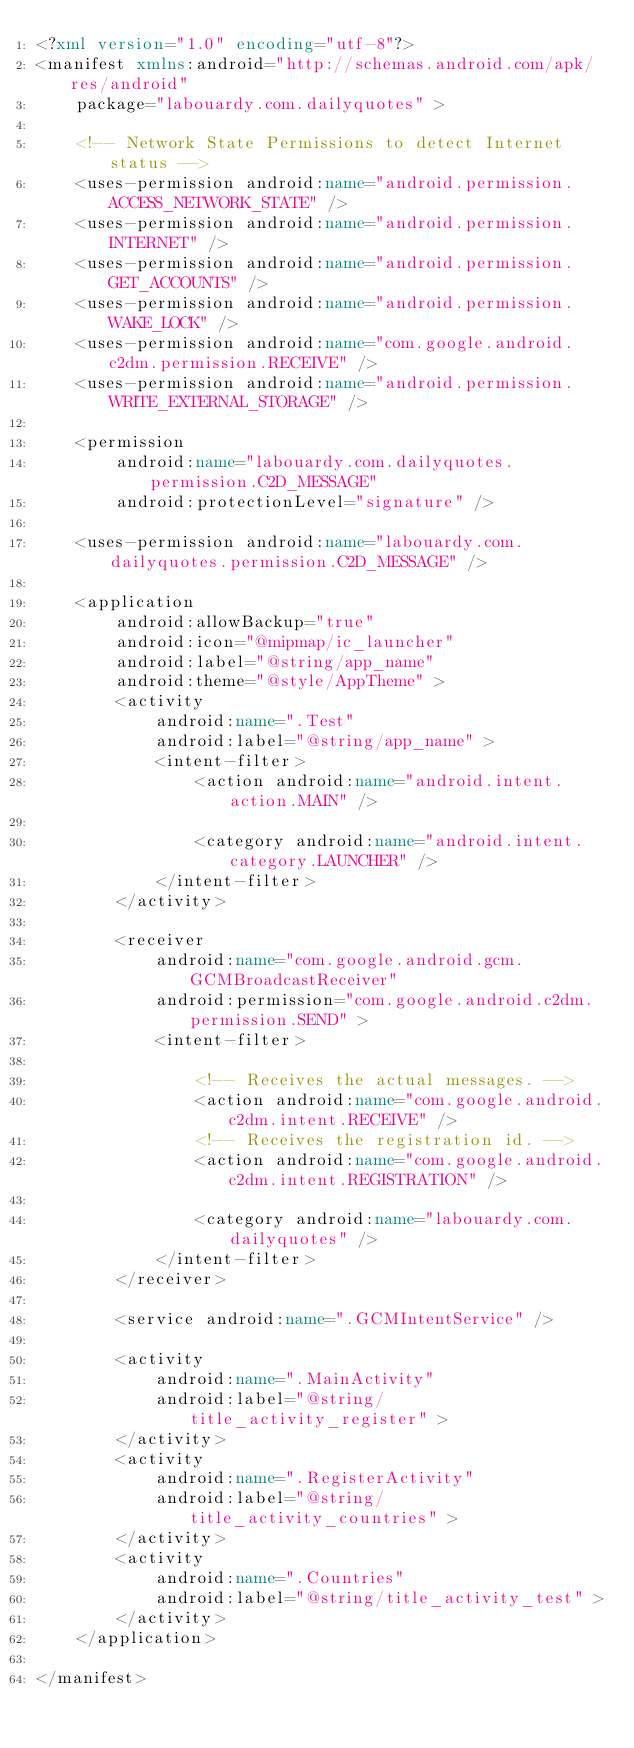<code> <loc_0><loc_0><loc_500><loc_500><_XML_><?xml version="1.0" encoding="utf-8"?>
<manifest xmlns:android="http://schemas.android.com/apk/res/android"
    package="labouardy.com.dailyquotes" >

    <!-- Network State Permissions to detect Internet status -->
    <uses-permission android:name="android.permission.ACCESS_NETWORK_STATE" />
    <uses-permission android:name="android.permission.INTERNET" />
    <uses-permission android:name="android.permission.GET_ACCOUNTS" />
    <uses-permission android:name="android.permission.WAKE_LOCK" />
    <uses-permission android:name="com.google.android.c2dm.permission.RECEIVE" />
    <uses-permission android:name="android.permission.WRITE_EXTERNAL_STORAGE" />

    <permission
        android:name="labouardy.com.dailyquotes.permission.C2D_MESSAGE"
        android:protectionLevel="signature" />

    <uses-permission android:name="labouardy.com.dailyquotes.permission.C2D_MESSAGE" />

    <application
        android:allowBackup="true"
        android:icon="@mipmap/ic_launcher"
        android:label="@string/app_name"
        android:theme="@style/AppTheme" >
        <activity
            android:name=".Test"
            android:label="@string/app_name" >
            <intent-filter>
                <action android:name="android.intent.action.MAIN" />

                <category android:name="android.intent.category.LAUNCHER" />
            </intent-filter>
        </activity>

        <receiver
            android:name="com.google.android.gcm.GCMBroadcastReceiver"
            android:permission="com.google.android.c2dm.permission.SEND" >
            <intent-filter>

                <!-- Receives the actual messages. -->
                <action android:name="com.google.android.c2dm.intent.RECEIVE" />
                <!-- Receives the registration id. -->
                <action android:name="com.google.android.c2dm.intent.REGISTRATION" />

                <category android:name="labouardy.com.dailyquotes" />
            </intent-filter>
        </receiver>

        <service android:name=".GCMIntentService" />

        <activity
            android:name=".MainActivity"
            android:label="@string/title_activity_register" >
        </activity>
        <activity
            android:name=".RegisterActivity"
            android:label="@string/title_activity_countries" >
        </activity>
        <activity
            android:name=".Countries"
            android:label="@string/title_activity_test" >
        </activity>
    </application>

</manifest>
</code> 